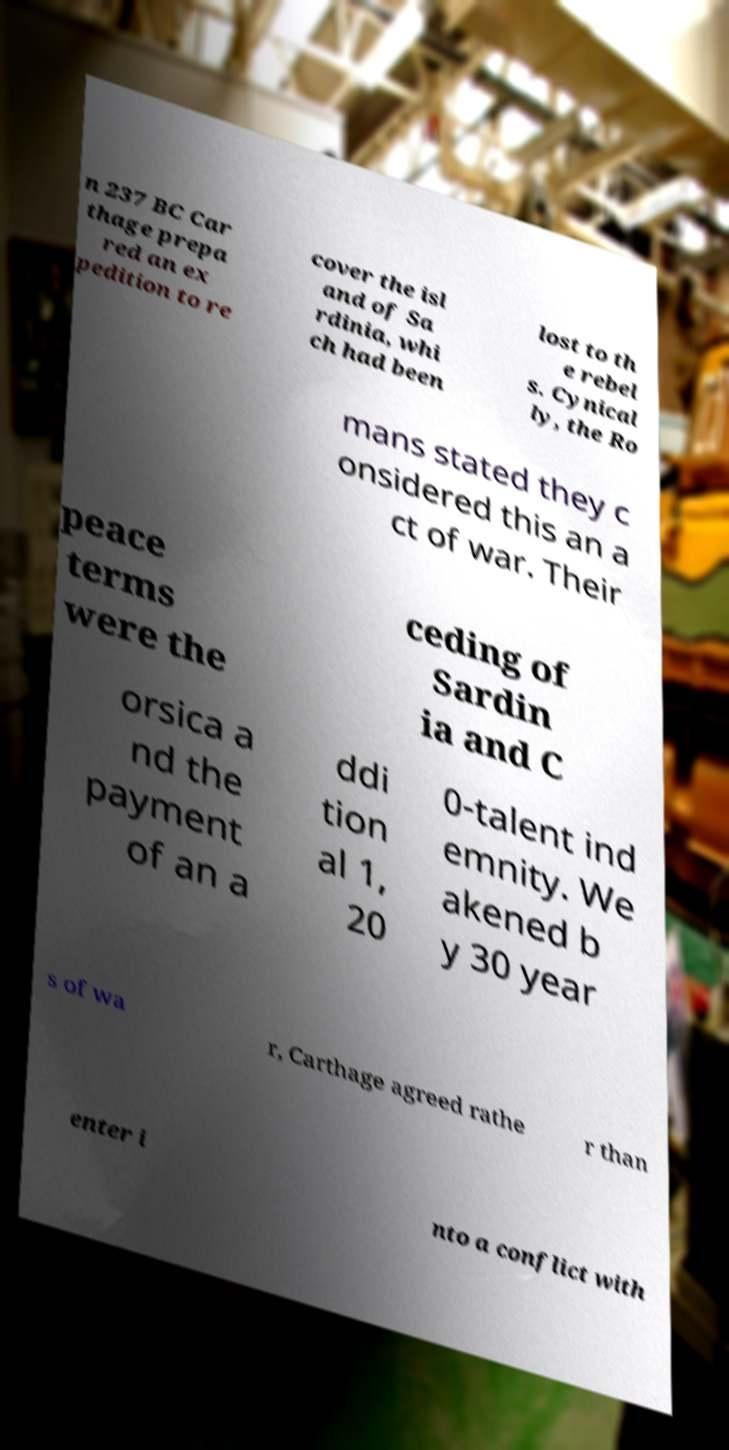I need the written content from this picture converted into text. Can you do that? n 237 BC Car thage prepa red an ex pedition to re cover the isl and of Sa rdinia, whi ch had been lost to th e rebel s. Cynical ly, the Ro mans stated they c onsidered this an a ct of war. Their peace terms were the ceding of Sardin ia and C orsica a nd the payment of an a ddi tion al 1, 20 0-talent ind emnity. We akened b y 30 year s of wa r, Carthage agreed rathe r than enter i nto a conflict with 